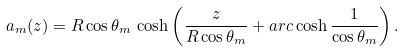Convert formula to latex. <formula><loc_0><loc_0><loc_500><loc_500>a _ { m } ( z ) = R \cos \theta _ { m } \, \cosh \left ( \frac { z } { R \cos \theta _ { m } } + a r c \cosh \frac { 1 } { \cos \theta _ { m } } \right ) .</formula> 